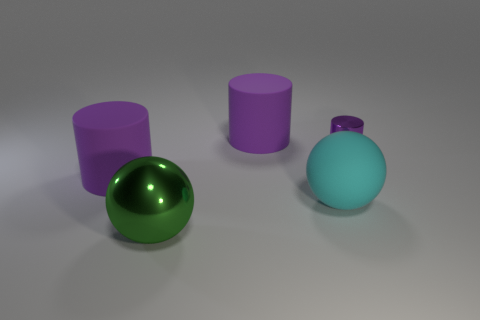Add 4 small blue rubber objects. How many objects exist? 9 Subtract all spheres. How many objects are left? 3 Add 1 cyan matte objects. How many cyan matte objects are left? 2 Add 1 blue metal spheres. How many blue metal spheres exist? 1 Subtract 0 red cubes. How many objects are left? 5 Subtract all yellow rubber things. Subtract all rubber cylinders. How many objects are left? 3 